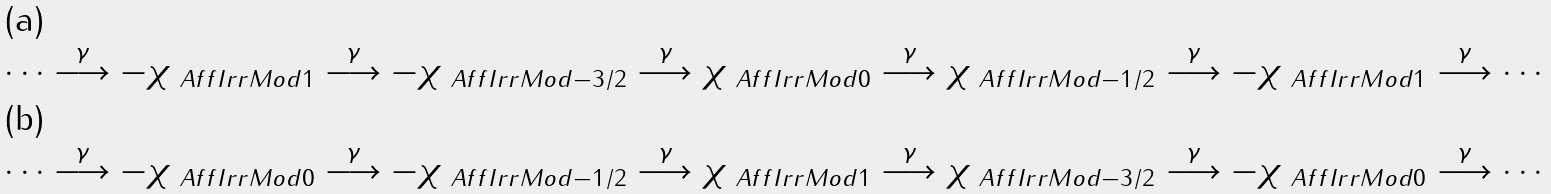Convert formula to latex. <formula><loc_0><loc_0><loc_500><loc_500>\cdots \overset { \gamma } { \longrightarrow } - \chi _ { \ A f f I r r M o d { 1 } } \overset { \gamma } { \longrightarrow } - \chi _ { \ A f f I r r M o d { - 3 / 2 } } \overset { \gamma } { \longrightarrow } \chi _ { \ A f f I r r M o d { 0 } } \overset { \gamma } { \longrightarrow } \chi _ { \ A f f I r r M o d { - 1 / 2 } } \overset { \gamma } { \longrightarrow } - \chi _ { \ A f f I r r M o d { 1 } } \overset { \gamma } { \longrightarrow } \cdots \\ \cdots \overset { \gamma } { \longrightarrow } - \chi _ { \ A f f I r r M o d { 0 } } \overset { \gamma } { \longrightarrow } - \chi _ { \ A f f I r r M o d { - 1 / 2 } } \overset { \gamma } { \longrightarrow } \chi _ { \ A f f I r r M o d { 1 } } \overset { \gamma } { \longrightarrow } \chi _ { \ A f f I r r M o d { - 3 / 2 } } \overset { \gamma } { \longrightarrow } - \chi _ { \ A f f I r r M o d { 0 } } \overset { \gamma } { \longrightarrow } \cdots</formula> 